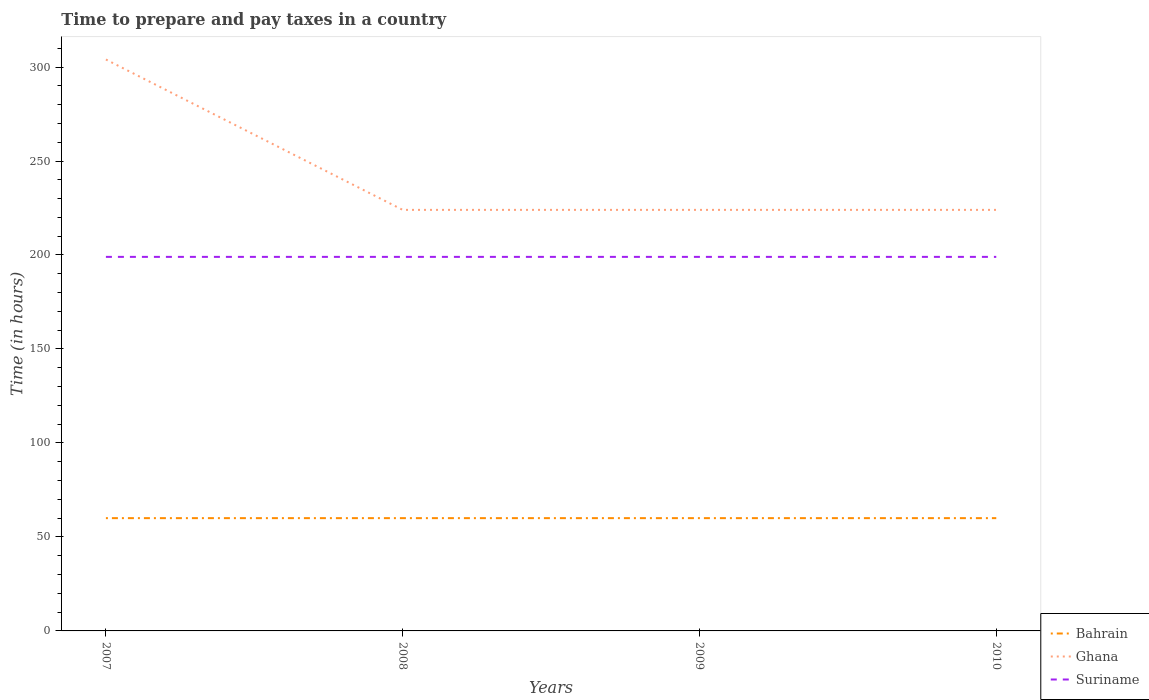Does the line corresponding to Bahrain intersect with the line corresponding to Suriname?
Make the answer very short. No. Across all years, what is the maximum number of hours required to prepare and pay taxes in Ghana?
Your answer should be very brief. 224. What is the total number of hours required to prepare and pay taxes in Ghana in the graph?
Offer a terse response. 0. What is the difference between the highest and the second highest number of hours required to prepare and pay taxes in Ghana?
Offer a terse response. 80. What is the difference between the highest and the lowest number of hours required to prepare and pay taxes in Suriname?
Your answer should be compact. 0. Is the number of hours required to prepare and pay taxes in Suriname strictly greater than the number of hours required to prepare and pay taxes in Ghana over the years?
Provide a succinct answer. Yes. How many lines are there?
Your response must be concise. 3. How many years are there in the graph?
Provide a succinct answer. 4. What is the difference between two consecutive major ticks on the Y-axis?
Offer a very short reply. 50. Does the graph contain any zero values?
Offer a terse response. No. How many legend labels are there?
Your answer should be compact. 3. What is the title of the graph?
Ensure brevity in your answer.  Time to prepare and pay taxes in a country. What is the label or title of the Y-axis?
Keep it short and to the point. Time (in hours). What is the Time (in hours) in Bahrain in 2007?
Keep it short and to the point. 60. What is the Time (in hours) of Ghana in 2007?
Your response must be concise. 304. What is the Time (in hours) of Suriname in 2007?
Your answer should be compact. 199. What is the Time (in hours) of Bahrain in 2008?
Your answer should be compact. 60. What is the Time (in hours) of Ghana in 2008?
Your answer should be very brief. 224. What is the Time (in hours) in Suriname in 2008?
Ensure brevity in your answer.  199. What is the Time (in hours) of Bahrain in 2009?
Provide a short and direct response. 60. What is the Time (in hours) of Ghana in 2009?
Your answer should be compact. 224. What is the Time (in hours) in Suriname in 2009?
Give a very brief answer. 199. What is the Time (in hours) in Ghana in 2010?
Provide a succinct answer. 224. What is the Time (in hours) in Suriname in 2010?
Offer a terse response. 199. Across all years, what is the maximum Time (in hours) of Bahrain?
Make the answer very short. 60. Across all years, what is the maximum Time (in hours) in Ghana?
Ensure brevity in your answer.  304. Across all years, what is the maximum Time (in hours) of Suriname?
Your answer should be very brief. 199. Across all years, what is the minimum Time (in hours) of Ghana?
Provide a succinct answer. 224. Across all years, what is the minimum Time (in hours) of Suriname?
Provide a short and direct response. 199. What is the total Time (in hours) in Bahrain in the graph?
Your response must be concise. 240. What is the total Time (in hours) of Ghana in the graph?
Your response must be concise. 976. What is the total Time (in hours) of Suriname in the graph?
Your response must be concise. 796. What is the difference between the Time (in hours) in Suriname in 2007 and that in 2008?
Your answer should be compact. 0. What is the difference between the Time (in hours) of Bahrain in 2007 and that in 2009?
Your response must be concise. 0. What is the difference between the Time (in hours) of Suriname in 2007 and that in 2009?
Your answer should be very brief. 0. What is the difference between the Time (in hours) of Ghana in 2007 and that in 2010?
Your answer should be very brief. 80. What is the difference between the Time (in hours) of Suriname in 2007 and that in 2010?
Make the answer very short. 0. What is the difference between the Time (in hours) in Bahrain in 2008 and that in 2009?
Your response must be concise. 0. What is the difference between the Time (in hours) of Suriname in 2008 and that in 2009?
Ensure brevity in your answer.  0. What is the difference between the Time (in hours) in Ghana in 2008 and that in 2010?
Your answer should be compact. 0. What is the difference between the Time (in hours) in Suriname in 2008 and that in 2010?
Make the answer very short. 0. What is the difference between the Time (in hours) in Bahrain in 2009 and that in 2010?
Provide a succinct answer. 0. What is the difference between the Time (in hours) of Ghana in 2009 and that in 2010?
Offer a terse response. 0. What is the difference between the Time (in hours) in Suriname in 2009 and that in 2010?
Give a very brief answer. 0. What is the difference between the Time (in hours) in Bahrain in 2007 and the Time (in hours) in Ghana in 2008?
Offer a terse response. -164. What is the difference between the Time (in hours) of Bahrain in 2007 and the Time (in hours) of Suriname in 2008?
Offer a terse response. -139. What is the difference between the Time (in hours) of Ghana in 2007 and the Time (in hours) of Suriname in 2008?
Keep it short and to the point. 105. What is the difference between the Time (in hours) of Bahrain in 2007 and the Time (in hours) of Ghana in 2009?
Give a very brief answer. -164. What is the difference between the Time (in hours) of Bahrain in 2007 and the Time (in hours) of Suriname in 2009?
Offer a terse response. -139. What is the difference between the Time (in hours) of Ghana in 2007 and the Time (in hours) of Suriname in 2009?
Your answer should be very brief. 105. What is the difference between the Time (in hours) in Bahrain in 2007 and the Time (in hours) in Ghana in 2010?
Ensure brevity in your answer.  -164. What is the difference between the Time (in hours) of Bahrain in 2007 and the Time (in hours) of Suriname in 2010?
Keep it short and to the point. -139. What is the difference between the Time (in hours) of Ghana in 2007 and the Time (in hours) of Suriname in 2010?
Provide a succinct answer. 105. What is the difference between the Time (in hours) of Bahrain in 2008 and the Time (in hours) of Ghana in 2009?
Ensure brevity in your answer.  -164. What is the difference between the Time (in hours) in Bahrain in 2008 and the Time (in hours) in Suriname in 2009?
Your answer should be very brief. -139. What is the difference between the Time (in hours) of Bahrain in 2008 and the Time (in hours) of Ghana in 2010?
Your answer should be very brief. -164. What is the difference between the Time (in hours) of Bahrain in 2008 and the Time (in hours) of Suriname in 2010?
Offer a very short reply. -139. What is the difference between the Time (in hours) in Bahrain in 2009 and the Time (in hours) in Ghana in 2010?
Keep it short and to the point. -164. What is the difference between the Time (in hours) of Bahrain in 2009 and the Time (in hours) of Suriname in 2010?
Provide a short and direct response. -139. What is the average Time (in hours) in Bahrain per year?
Ensure brevity in your answer.  60. What is the average Time (in hours) of Ghana per year?
Your response must be concise. 244. What is the average Time (in hours) of Suriname per year?
Offer a very short reply. 199. In the year 2007, what is the difference between the Time (in hours) in Bahrain and Time (in hours) in Ghana?
Offer a terse response. -244. In the year 2007, what is the difference between the Time (in hours) of Bahrain and Time (in hours) of Suriname?
Give a very brief answer. -139. In the year 2007, what is the difference between the Time (in hours) of Ghana and Time (in hours) of Suriname?
Offer a terse response. 105. In the year 2008, what is the difference between the Time (in hours) in Bahrain and Time (in hours) in Ghana?
Make the answer very short. -164. In the year 2008, what is the difference between the Time (in hours) of Bahrain and Time (in hours) of Suriname?
Provide a succinct answer. -139. In the year 2009, what is the difference between the Time (in hours) of Bahrain and Time (in hours) of Ghana?
Your answer should be compact. -164. In the year 2009, what is the difference between the Time (in hours) of Bahrain and Time (in hours) of Suriname?
Your answer should be very brief. -139. In the year 2009, what is the difference between the Time (in hours) of Ghana and Time (in hours) of Suriname?
Provide a succinct answer. 25. In the year 2010, what is the difference between the Time (in hours) of Bahrain and Time (in hours) of Ghana?
Keep it short and to the point. -164. In the year 2010, what is the difference between the Time (in hours) of Bahrain and Time (in hours) of Suriname?
Your response must be concise. -139. What is the ratio of the Time (in hours) of Bahrain in 2007 to that in 2008?
Your response must be concise. 1. What is the ratio of the Time (in hours) in Ghana in 2007 to that in 2008?
Provide a short and direct response. 1.36. What is the ratio of the Time (in hours) of Bahrain in 2007 to that in 2009?
Provide a short and direct response. 1. What is the ratio of the Time (in hours) in Ghana in 2007 to that in 2009?
Your answer should be compact. 1.36. What is the ratio of the Time (in hours) of Ghana in 2007 to that in 2010?
Your answer should be very brief. 1.36. What is the ratio of the Time (in hours) of Bahrain in 2008 to that in 2009?
Make the answer very short. 1. What is the ratio of the Time (in hours) in Suriname in 2008 to that in 2009?
Ensure brevity in your answer.  1. What is the ratio of the Time (in hours) of Ghana in 2008 to that in 2010?
Offer a terse response. 1. What is the ratio of the Time (in hours) in Suriname in 2008 to that in 2010?
Make the answer very short. 1. What is the ratio of the Time (in hours) in Suriname in 2009 to that in 2010?
Your answer should be compact. 1. What is the difference between the highest and the second highest Time (in hours) in Bahrain?
Your answer should be compact. 0. What is the difference between the highest and the lowest Time (in hours) of Ghana?
Give a very brief answer. 80. What is the difference between the highest and the lowest Time (in hours) in Suriname?
Make the answer very short. 0. 